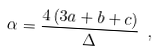Convert formula to latex. <formula><loc_0><loc_0><loc_500><loc_500>\alpha = \frac { 4 \, ( 3 a + b + c ) } \Delta \ ,</formula> 